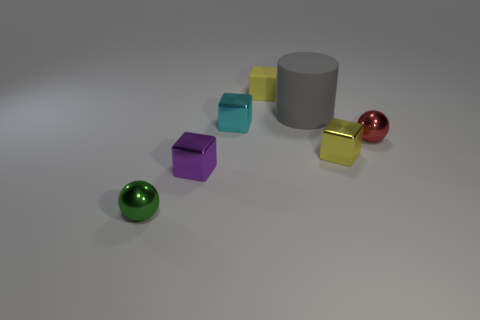Subtract all blue cubes. Subtract all blue cylinders. How many cubes are left? 4 Add 1 purple blocks. How many objects exist? 8 Subtract all blocks. How many objects are left? 3 Subtract 0 gray balls. How many objects are left? 7 Subtract all large blue blocks. Subtract all small purple shiny things. How many objects are left? 6 Add 3 large gray things. How many large gray things are left? 4 Add 5 small yellow metal spheres. How many small yellow metal spheres exist? 5 